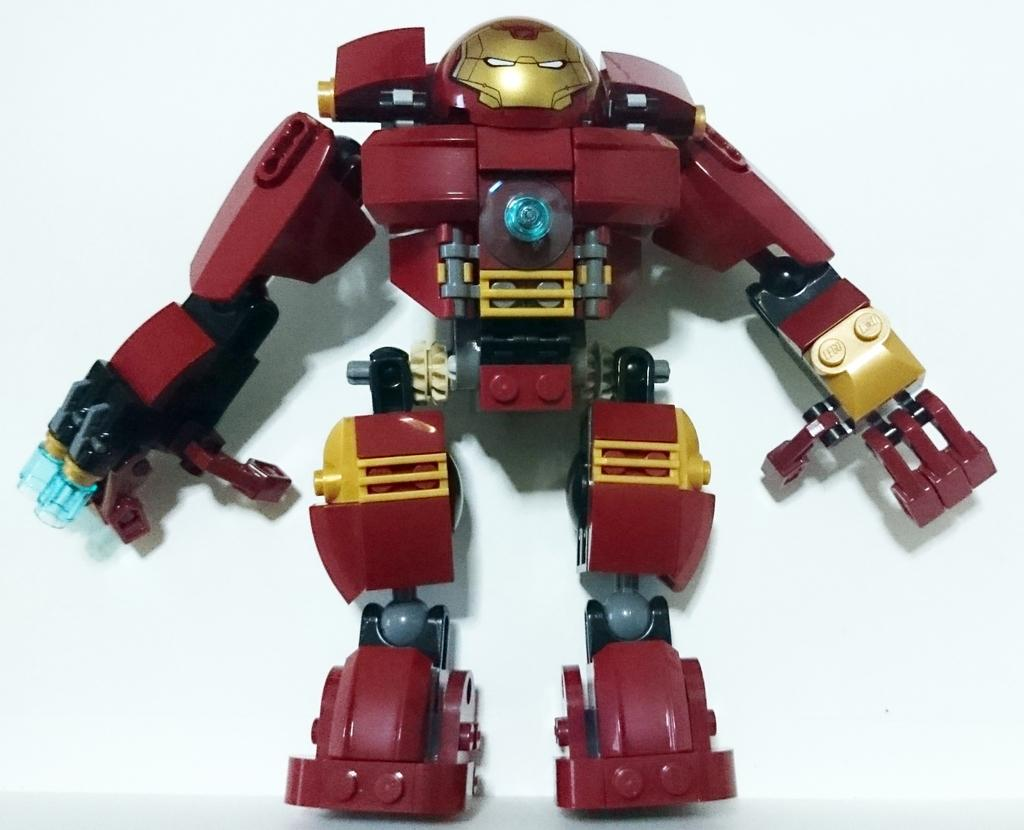What is the main subject of the image? There is a red color Lego robot in the image. What color is the Lego robot? The Lego robot is red. What is the background color in the image? The background of the image is white. Can you see the face of the person holding the eggnog in the image? There is no person holding eggnog in the image, nor is there any eggnog present. 